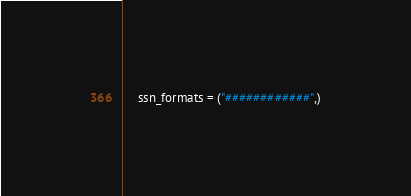<code> <loc_0><loc_0><loc_500><loc_500><_Python_>    ssn_formats = ("############",)
</code> 